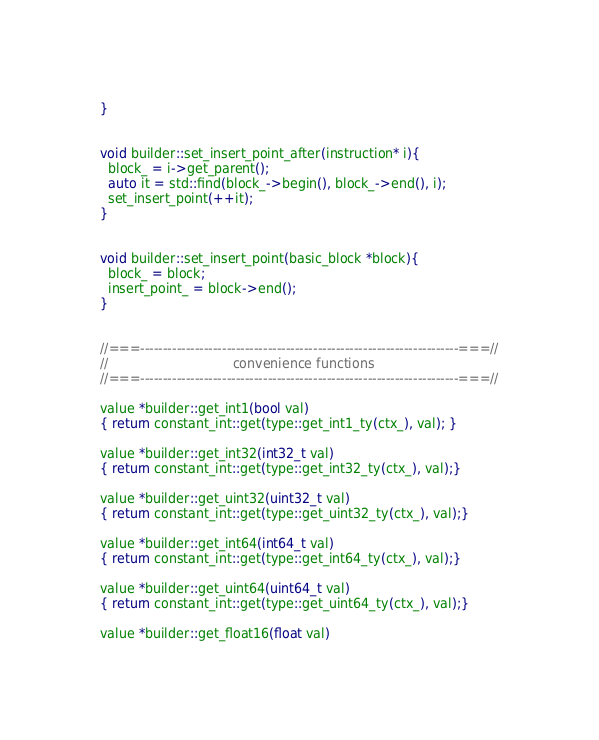<code> <loc_0><loc_0><loc_500><loc_500><_C++_>}


void builder::set_insert_point_after(instruction* i){
  block_ = i->get_parent();
  auto it = std::find(block_->begin(), block_->end(), i);
  set_insert_point(++it);
}


void builder::set_insert_point(basic_block *block){
  block_ = block;
  insert_point_ = block->end();
}


//===----------------------------------------------------------------------===//
//                               convenience functions
//===----------------------------------------------------------------------===//

value *builder::get_int1(bool val)
{ return constant_int::get(type::get_int1_ty(ctx_), val); }

value *builder::get_int32(int32_t val)
{ return constant_int::get(type::get_int32_ty(ctx_), val);}

value *builder::get_uint32(uint32_t val)
{ return constant_int::get(type::get_uint32_ty(ctx_), val);}

value *builder::get_int64(int64_t val)
{ return constant_int::get(type::get_int64_ty(ctx_), val);}

value *builder::get_uint64(uint64_t val)
{ return constant_int::get(type::get_uint64_ty(ctx_), val);}

value *builder::get_float16(float val)</code> 